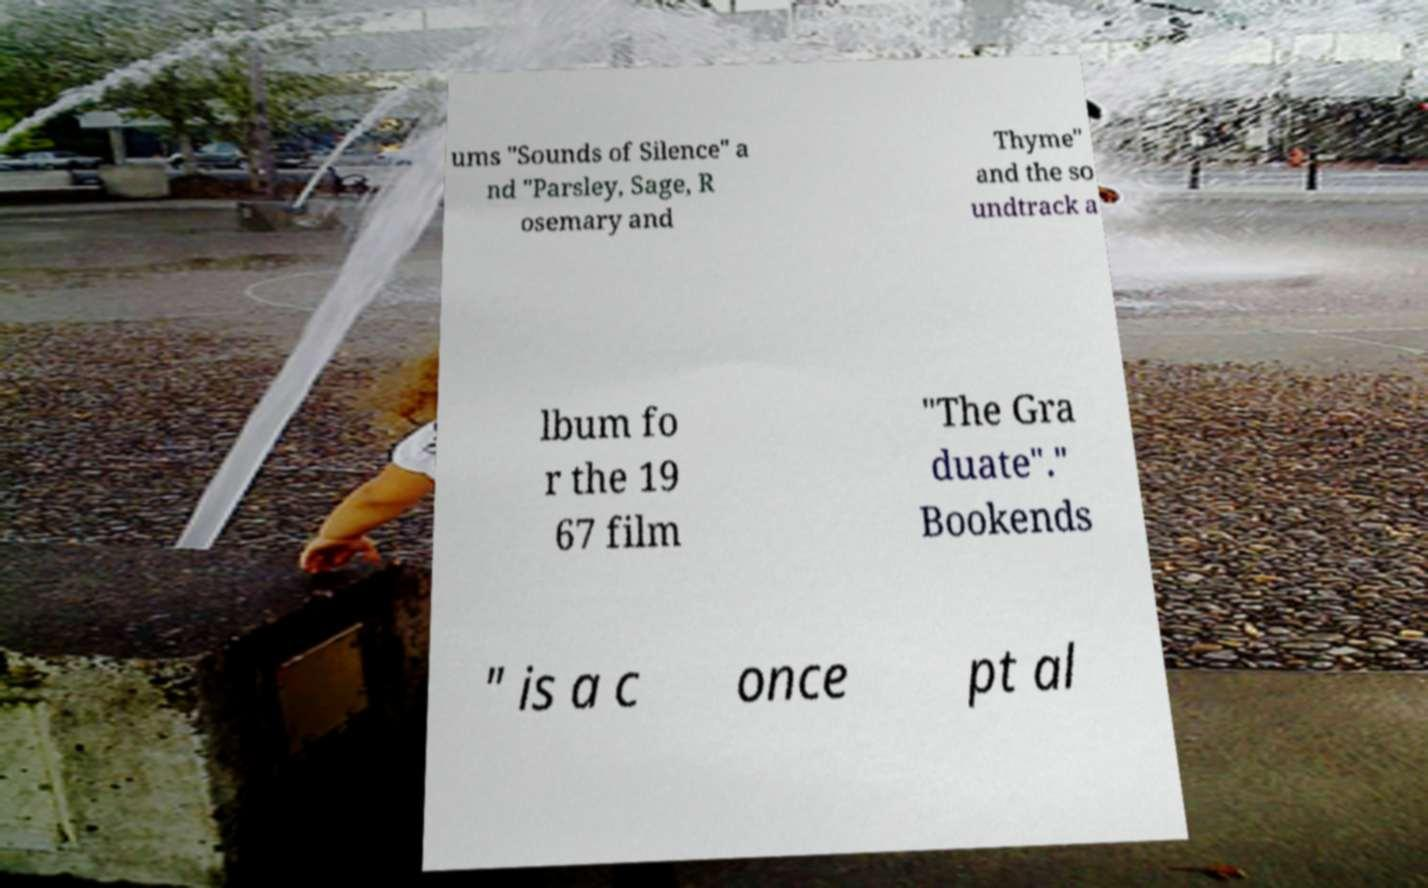Could you extract and type out the text from this image? ums "Sounds of Silence" a nd "Parsley, Sage, R osemary and Thyme" and the so undtrack a lbum fo r the 19 67 film "The Gra duate"." Bookends " is a c once pt al 